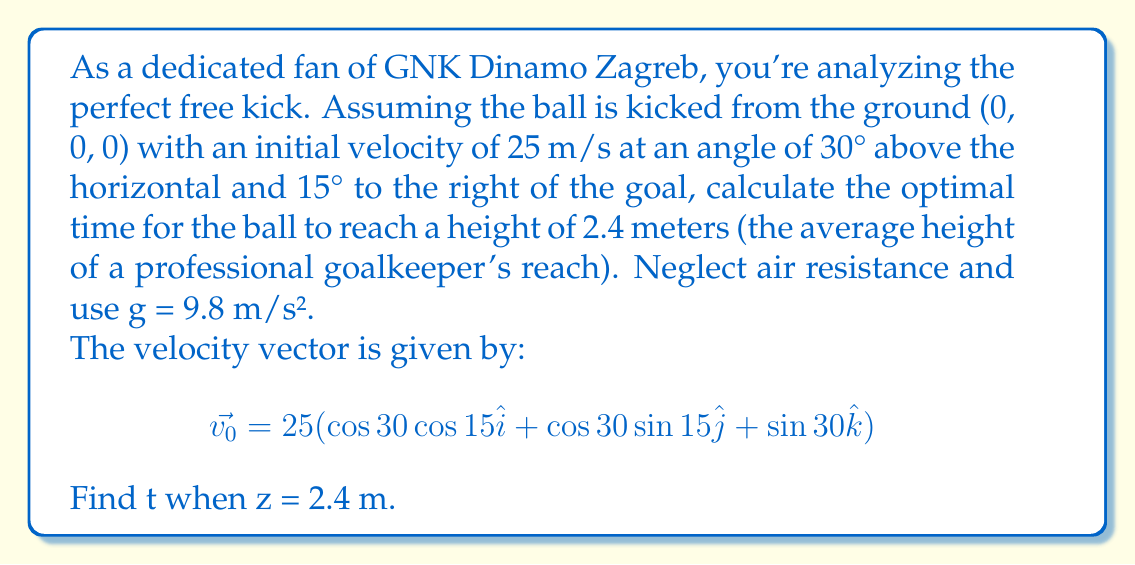Can you answer this question? Let's approach this step-by-step:

1) First, we need to break down the initial velocity vector into its components:

   $v_{0x} = 25 \cos 30° \cos 15° = 21.04$ m/s
   $v_{0y} = 25 \cos 30° \sin 15° = 5.63$ m/s
   $v_{0z} = 25 \sin 30° = 12.5$ m/s

2) The position vector as a function of time is given by:

   $$\vec{r}(t) = (v_{0x}t)\hat{i} + (v_{0y}t)\hat{j} + (v_{0z}t - \frac{1}{2}gt^2)\hat{k}$$

3) We're interested in the z-component, which reaches 2.4 m:

   $$z(t) = v_{0z}t - \frac{1}{2}gt^2 = 2.4$$

4) Substituting the values:

   $$12.5t - 4.9t^2 = 2.4$$

5) Rearranging into standard quadratic form:

   $$4.9t^2 - 12.5t + 2.4 = 0$$

6) Using the quadratic formula, $t = \frac{-b \pm \sqrt{b^2 - 4ac}}{2a}$, where a = 4.9, b = -12.5, and c = 2.4:

   $$t = \frac{12.5 \pm \sqrt{156.25 - 47.04}}{9.8} = \frac{12.5 \pm 10.91}{9.8}$$

7) This gives us two solutions:
   
   $t_1 = 2.39$ s
   $t_2 = 0.16$ s

8) The larger value, 2.39 s, represents the time when the ball reaches 2.4 m on its way down. The smaller value, 0.16 s, is when it reaches 2.4 m on its way up.

For the optimal time to reach the goalkeeper's maximum reach, we want the ball to be at its highest point, which is the larger value.
Answer: The optimal time for the ball to reach a height of 2.4 meters is approximately 2.39 seconds. 